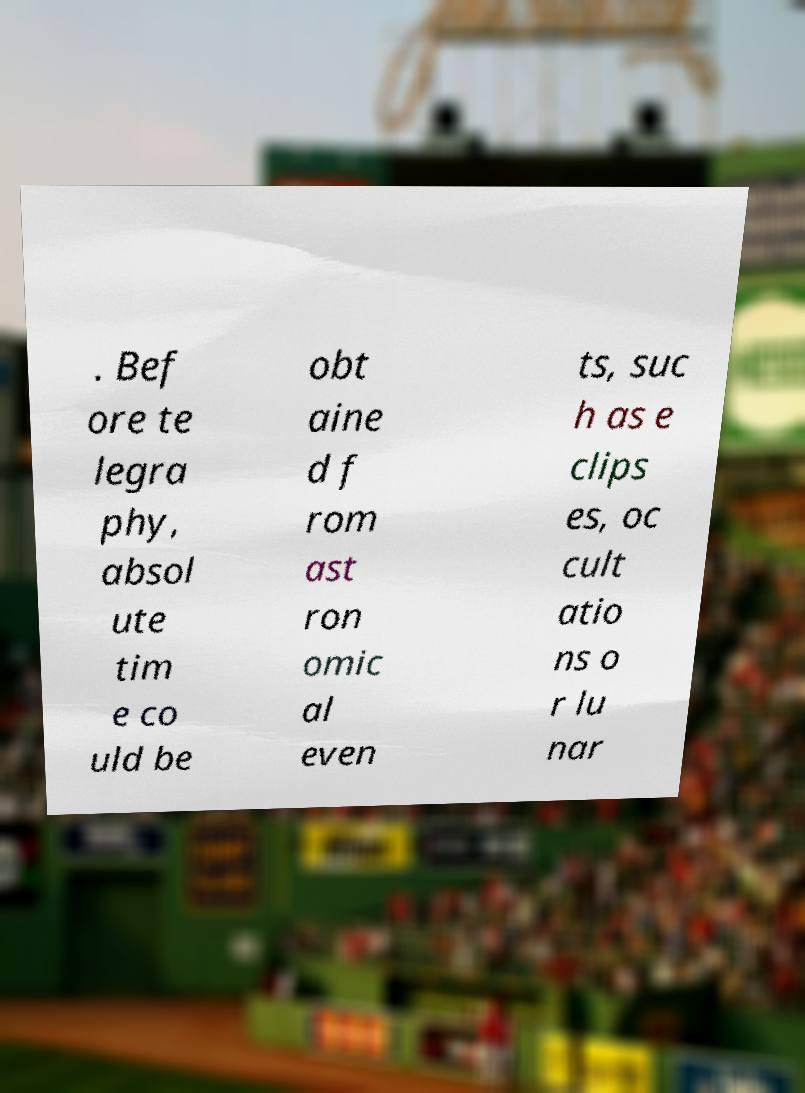Can you accurately transcribe the text from the provided image for me? . Bef ore te legra phy, absol ute tim e co uld be obt aine d f rom ast ron omic al even ts, suc h as e clips es, oc cult atio ns o r lu nar 